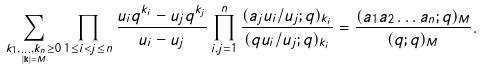<formula> <loc_0><loc_0><loc_500><loc_500>\sum _ { \underset { | { \mathbf k } | = M } { k _ { 1 } , \dots , k _ { n } \geq 0 } } \prod _ { 1 \leq i < j \leq n } \frac { u _ { i } q ^ { k _ { i } } - u _ { j } q ^ { k _ { j } } } { u _ { i } - u _ { j } } \prod _ { i , j = 1 } ^ { n } \frac { ( a _ { j } u _ { i } / u _ { j } ; q ) _ { k _ { i } } } { ( q u _ { i } / u _ { j } ; q ) _ { k _ { i } } } = \frac { ( a _ { 1 } a _ { 2 } \dots a _ { n } ; q ) _ { M } } { ( q ; q ) _ { M } } .</formula> 